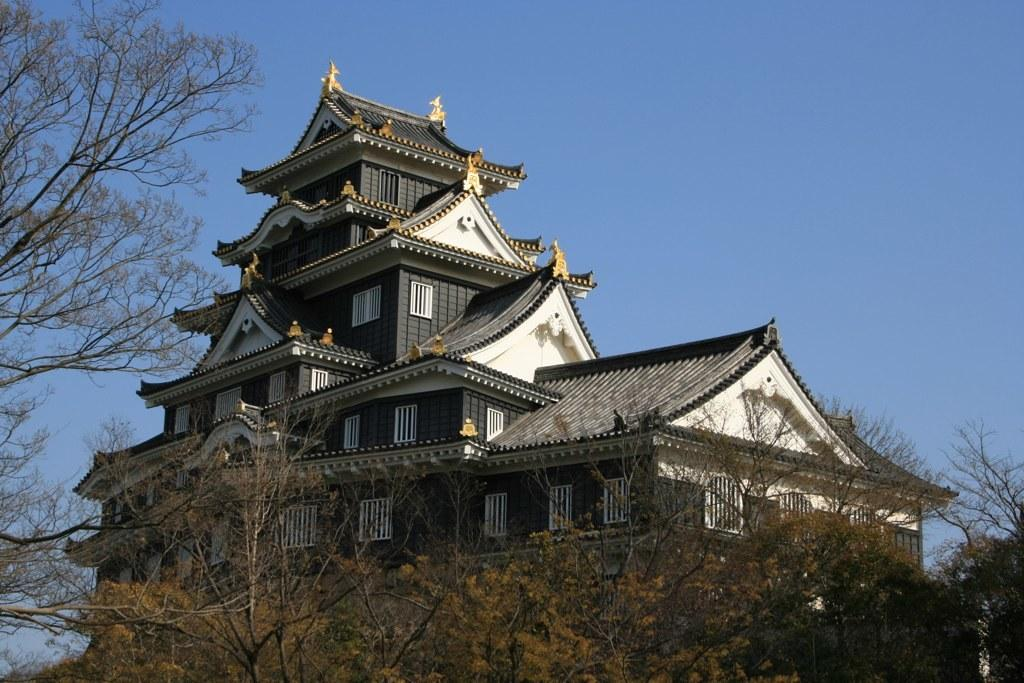What type of structure is present in the image? There is a house in the image. What features can be seen on the house? The house has windows. What type of vegetation is visible in the image? There are trees visible in the image. What is visible in the background of the image? The sky is visible in the background of the image. Can you hear the birds coughing in the nest in the image? There is no nest or birds present in the image, so it is not possible to hear any coughing. 